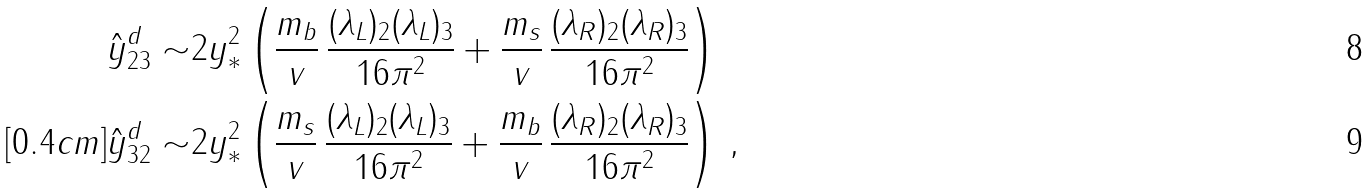<formula> <loc_0><loc_0><loc_500><loc_500>\hat { y } _ { 2 3 } ^ { d } \sim & 2 y _ { * } ^ { 2 } \left ( \frac { m _ { b } } { v } \, \frac { ( \lambda _ { L } ) _ { 2 } ( \lambda _ { L } ) _ { 3 } } { 1 6 \pi ^ { 2 } } + \frac { m _ { s } } { v } \, \frac { ( \lambda _ { R } ) _ { 2 } ( \lambda _ { R } ) _ { 3 } } { 1 6 \pi ^ { 2 } } \right ) \\ [ 0 . 4 c m ] \hat { y } _ { 3 2 } ^ { d } \sim & 2 y _ { * } ^ { 2 } \left ( \frac { m _ { s } } { v } \, \frac { ( \lambda _ { L } ) _ { 2 } ( \lambda _ { L } ) _ { 3 } } { 1 6 \pi ^ { 2 } } + \frac { m _ { b } } { v } \, \frac { ( \lambda _ { R } ) _ { 2 } ( \lambda _ { R } ) _ { 3 } } { 1 6 \pi ^ { 2 } } \right ) \, ,</formula> 